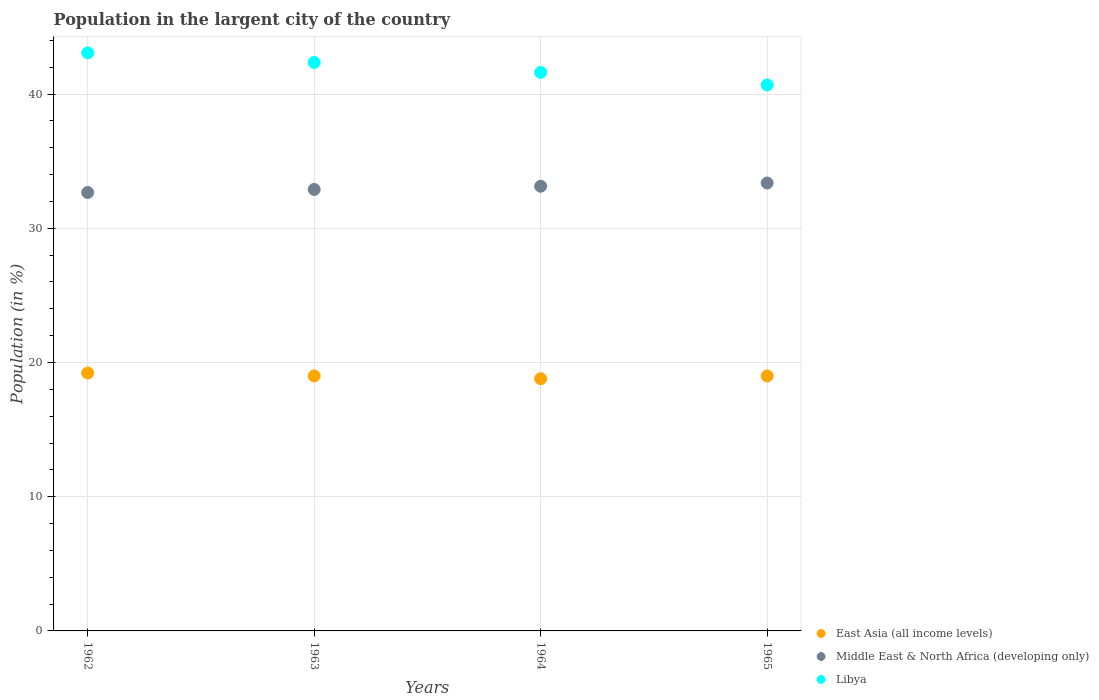How many different coloured dotlines are there?
Provide a short and direct response. 3. What is the percentage of population in the largent city in Libya in 1962?
Your answer should be compact. 43.07. Across all years, what is the maximum percentage of population in the largent city in Middle East & North Africa (developing only)?
Offer a terse response. 33.37. Across all years, what is the minimum percentage of population in the largent city in Middle East & North Africa (developing only)?
Offer a very short reply. 32.67. In which year was the percentage of population in the largent city in Libya maximum?
Offer a terse response. 1962. What is the total percentage of population in the largent city in East Asia (all income levels) in the graph?
Provide a short and direct response. 76.01. What is the difference between the percentage of population in the largent city in East Asia (all income levels) in 1962 and that in 1965?
Your answer should be very brief. 0.22. What is the difference between the percentage of population in the largent city in Libya in 1962 and the percentage of population in the largent city in Middle East & North Africa (developing only) in 1965?
Offer a terse response. 9.7. What is the average percentage of population in the largent city in East Asia (all income levels) per year?
Provide a short and direct response. 19. In the year 1965, what is the difference between the percentage of population in the largent city in Middle East & North Africa (developing only) and percentage of population in the largent city in East Asia (all income levels)?
Keep it short and to the point. 14.37. What is the ratio of the percentage of population in the largent city in Middle East & North Africa (developing only) in 1963 to that in 1964?
Offer a terse response. 0.99. Is the percentage of population in the largent city in Libya in 1962 less than that in 1965?
Offer a terse response. No. What is the difference between the highest and the second highest percentage of population in the largent city in Libya?
Provide a succinct answer. 0.71. What is the difference between the highest and the lowest percentage of population in the largent city in East Asia (all income levels)?
Make the answer very short. 0.42. Is it the case that in every year, the sum of the percentage of population in the largent city in Libya and percentage of population in the largent city in East Asia (all income levels)  is greater than the percentage of population in the largent city in Middle East & North Africa (developing only)?
Provide a short and direct response. Yes. Does the percentage of population in the largent city in East Asia (all income levels) monotonically increase over the years?
Keep it short and to the point. No. How many dotlines are there?
Make the answer very short. 3. How many years are there in the graph?
Give a very brief answer. 4. Are the values on the major ticks of Y-axis written in scientific E-notation?
Provide a short and direct response. No. Does the graph contain any zero values?
Keep it short and to the point. No. Does the graph contain grids?
Give a very brief answer. Yes. Where does the legend appear in the graph?
Provide a succinct answer. Bottom right. How are the legend labels stacked?
Your answer should be very brief. Vertical. What is the title of the graph?
Make the answer very short. Population in the largent city of the country. What is the label or title of the X-axis?
Give a very brief answer. Years. What is the label or title of the Y-axis?
Your answer should be compact. Population (in %). What is the Population (in %) of East Asia (all income levels) in 1962?
Offer a terse response. 19.22. What is the Population (in %) in Middle East & North Africa (developing only) in 1962?
Offer a very short reply. 32.67. What is the Population (in %) in Libya in 1962?
Give a very brief answer. 43.07. What is the Population (in %) in East Asia (all income levels) in 1963?
Ensure brevity in your answer.  19. What is the Population (in %) of Middle East & North Africa (developing only) in 1963?
Offer a very short reply. 32.89. What is the Population (in %) in Libya in 1963?
Provide a short and direct response. 42.36. What is the Population (in %) in East Asia (all income levels) in 1964?
Keep it short and to the point. 18.79. What is the Population (in %) of Middle East & North Africa (developing only) in 1964?
Provide a succinct answer. 33.13. What is the Population (in %) of Libya in 1964?
Your answer should be very brief. 41.62. What is the Population (in %) in East Asia (all income levels) in 1965?
Offer a very short reply. 19. What is the Population (in %) of Middle East & North Africa (developing only) in 1965?
Give a very brief answer. 33.37. What is the Population (in %) in Libya in 1965?
Offer a terse response. 40.68. Across all years, what is the maximum Population (in %) of East Asia (all income levels)?
Your answer should be very brief. 19.22. Across all years, what is the maximum Population (in %) of Middle East & North Africa (developing only)?
Provide a succinct answer. 33.37. Across all years, what is the maximum Population (in %) in Libya?
Make the answer very short. 43.07. Across all years, what is the minimum Population (in %) of East Asia (all income levels)?
Keep it short and to the point. 18.79. Across all years, what is the minimum Population (in %) of Middle East & North Africa (developing only)?
Make the answer very short. 32.67. Across all years, what is the minimum Population (in %) of Libya?
Give a very brief answer. 40.68. What is the total Population (in %) of East Asia (all income levels) in the graph?
Offer a very short reply. 76.01. What is the total Population (in %) of Middle East & North Africa (developing only) in the graph?
Keep it short and to the point. 132.07. What is the total Population (in %) in Libya in the graph?
Ensure brevity in your answer.  167.72. What is the difference between the Population (in %) of East Asia (all income levels) in 1962 and that in 1963?
Provide a succinct answer. 0.22. What is the difference between the Population (in %) in Middle East & North Africa (developing only) in 1962 and that in 1963?
Offer a terse response. -0.23. What is the difference between the Population (in %) of Libya in 1962 and that in 1963?
Give a very brief answer. 0.71. What is the difference between the Population (in %) in East Asia (all income levels) in 1962 and that in 1964?
Ensure brevity in your answer.  0.42. What is the difference between the Population (in %) of Middle East & North Africa (developing only) in 1962 and that in 1964?
Offer a very short reply. -0.46. What is the difference between the Population (in %) of Libya in 1962 and that in 1964?
Keep it short and to the point. 1.45. What is the difference between the Population (in %) of East Asia (all income levels) in 1962 and that in 1965?
Make the answer very short. 0.22. What is the difference between the Population (in %) of Middle East & North Africa (developing only) in 1962 and that in 1965?
Your answer should be very brief. -0.7. What is the difference between the Population (in %) of Libya in 1962 and that in 1965?
Keep it short and to the point. 2.39. What is the difference between the Population (in %) in East Asia (all income levels) in 1963 and that in 1964?
Make the answer very short. 0.21. What is the difference between the Population (in %) in Middle East & North Africa (developing only) in 1963 and that in 1964?
Keep it short and to the point. -0.24. What is the difference between the Population (in %) of Libya in 1963 and that in 1964?
Your answer should be very brief. 0.74. What is the difference between the Population (in %) in East Asia (all income levels) in 1963 and that in 1965?
Ensure brevity in your answer.  0. What is the difference between the Population (in %) in Middle East & North Africa (developing only) in 1963 and that in 1965?
Your answer should be compact. -0.48. What is the difference between the Population (in %) of Libya in 1963 and that in 1965?
Offer a terse response. 1.68. What is the difference between the Population (in %) of East Asia (all income levels) in 1964 and that in 1965?
Give a very brief answer. -0.2. What is the difference between the Population (in %) in Middle East & North Africa (developing only) in 1964 and that in 1965?
Ensure brevity in your answer.  -0.24. What is the difference between the Population (in %) of Libya in 1964 and that in 1965?
Provide a succinct answer. 0.94. What is the difference between the Population (in %) of East Asia (all income levels) in 1962 and the Population (in %) of Middle East & North Africa (developing only) in 1963?
Offer a very short reply. -13.68. What is the difference between the Population (in %) of East Asia (all income levels) in 1962 and the Population (in %) of Libya in 1963?
Give a very brief answer. -23.14. What is the difference between the Population (in %) of Middle East & North Africa (developing only) in 1962 and the Population (in %) of Libya in 1963?
Your response must be concise. -9.69. What is the difference between the Population (in %) of East Asia (all income levels) in 1962 and the Population (in %) of Middle East & North Africa (developing only) in 1964?
Your answer should be very brief. -13.92. What is the difference between the Population (in %) of East Asia (all income levels) in 1962 and the Population (in %) of Libya in 1964?
Give a very brief answer. -22.4. What is the difference between the Population (in %) in Middle East & North Africa (developing only) in 1962 and the Population (in %) in Libya in 1964?
Offer a very short reply. -8.95. What is the difference between the Population (in %) in East Asia (all income levels) in 1962 and the Population (in %) in Middle East & North Africa (developing only) in 1965?
Provide a succinct answer. -14.15. What is the difference between the Population (in %) in East Asia (all income levels) in 1962 and the Population (in %) in Libya in 1965?
Offer a very short reply. -21.46. What is the difference between the Population (in %) in Middle East & North Africa (developing only) in 1962 and the Population (in %) in Libya in 1965?
Your answer should be compact. -8.01. What is the difference between the Population (in %) of East Asia (all income levels) in 1963 and the Population (in %) of Middle East & North Africa (developing only) in 1964?
Offer a very short reply. -14.13. What is the difference between the Population (in %) of East Asia (all income levels) in 1963 and the Population (in %) of Libya in 1964?
Make the answer very short. -22.62. What is the difference between the Population (in %) of Middle East & North Africa (developing only) in 1963 and the Population (in %) of Libya in 1964?
Make the answer very short. -8.72. What is the difference between the Population (in %) in East Asia (all income levels) in 1963 and the Population (in %) in Middle East & North Africa (developing only) in 1965?
Offer a terse response. -14.37. What is the difference between the Population (in %) in East Asia (all income levels) in 1963 and the Population (in %) in Libya in 1965?
Make the answer very short. -21.68. What is the difference between the Population (in %) in Middle East & North Africa (developing only) in 1963 and the Population (in %) in Libya in 1965?
Ensure brevity in your answer.  -7.79. What is the difference between the Population (in %) of East Asia (all income levels) in 1964 and the Population (in %) of Middle East & North Africa (developing only) in 1965?
Ensure brevity in your answer.  -14.58. What is the difference between the Population (in %) of East Asia (all income levels) in 1964 and the Population (in %) of Libya in 1965?
Your response must be concise. -21.89. What is the difference between the Population (in %) of Middle East & North Africa (developing only) in 1964 and the Population (in %) of Libya in 1965?
Your answer should be very brief. -7.55. What is the average Population (in %) of East Asia (all income levels) per year?
Keep it short and to the point. 19. What is the average Population (in %) in Middle East & North Africa (developing only) per year?
Your answer should be compact. 33.02. What is the average Population (in %) of Libya per year?
Provide a short and direct response. 41.93. In the year 1962, what is the difference between the Population (in %) of East Asia (all income levels) and Population (in %) of Middle East & North Africa (developing only)?
Offer a terse response. -13.45. In the year 1962, what is the difference between the Population (in %) of East Asia (all income levels) and Population (in %) of Libya?
Your response must be concise. -23.85. In the year 1962, what is the difference between the Population (in %) in Middle East & North Africa (developing only) and Population (in %) in Libya?
Provide a succinct answer. -10.4. In the year 1963, what is the difference between the Population (in %) in East Asia (all income levels) and Population (in %) in Middle East & North Africa (developing only)?
Offer a very short reply. -13.89. In the year 1963, what is the difference between the Population (in %) of East Asia (all income levels) and Population (in %) of Libya?
Provide a short and direct response. -23.36. In the year 1963, what is the difference between the Population (in %) in Middle East & North Africa (developing only) and Population (in %) in Libya?
Make the answer very short. -9.46. In the year 1964, what is the difference between the Population (in %) in East Asia (all income levels) and Population (in %) in Middle East & North Africa (developing only)?
Ensure brevity in your answer.  -14.34. In the year 1964, what is the difference between the Population (in %) of East Asia (all income levels) and Population (in %) of Libya?
Your response must be concise. -22.82. In the year 1964, what is the difference between the Population (in %) of Middle East & North Africa (developing only) and Population (in %) of Libya?
Provide a succinct answer. -8.48. In the year 1965, what is the difference between the Population (in %) in East Asia (all income levels) and Population (in %) in Middle East & North Africa (developing only)?
Make the answer very short. -14.37. In the year 1965, what is the difference between the Population (in %) in East Asia (all income levels) and Population (in %) in Libya?
Provide a short and direct response. -21.68. In the year 1965, what is the difference between the Population (in %) of Middle East & North Africa (developing only) and Population (in %) of Libya?
Keep it short and to the point. -7.31. What is the ratio of the Population (in %) of East Asia (all income levels) in 1962 to that in 1963?
Keep it short and to the point. 1.01. What is the ratio of the Population (in %) in Middle East & North Africa (developing only) in 1962 to that in 1963?
Offer a very short reply. 0.99. What is the ratio of the Population (in %) of Libya in 1962 to that in 1963?
Ensure brevity in your answer.  1.02. What is the ratio of the Population (in %) of East Asia (all income levels) in 1962 to that in 1964?
Offer a very short reply. 1.02. What is the ratio of the Population (in %) in Libya in 1962 to that in 1964?
Make the answer very short. 1.03. What is the ratio of the Population (in %) in East Asia (all income levels) in 1962 to that in 1965?
Offer a terse response. 1.01. What is the ratio of the Population (in %) of Middle East & North Africa (developing only) in 1962 to that in 1965?
Give a very brief answer. 0.98. What is the ratio of the Population (in %) in Libya in 1962 to that in 1965?
Your answer should be compact. 1.06. What is the ratio of the Population (in %) of East Asia (all income levels) in 1963 to that in 1964?
Ensure brevity in your answer.  1.01. What is the ratio of the Population (in %) of Middle East & North Africa (developing only) in 1963 to that in 1964?
Give a very brief answer. 0.99. What is the ratio of the Population (in %) of Libya in 1963 to that in 1964?
Provide a succinct answer. 1.02. What is the ratio of the Population (in %) of Middle East & North Africa (developing only) in 1963 to that in 1965?
Offer a very short reply. 0.99. What is the ratio of the Population (in %) in Libya in 1963 to that in 1965?
Make the answer very short. 1.04. What is the ratio of the Population (in %) of East Asia (all income levels) in 1964 to that in 1965?
Provide a short and direct response. 0.99. What is the difference between the highest and the second highest Population (in %) of East Asia (all income levels)?
Offer a terse response. 0.22. What is the difference between the highest and the second highest Population (in %) of Middle East & North Africa (developing only)?
Give a very brief answer. 0.24. What is the difference between the highest and the second highest Population (in %) in Libya?
Make the answer very short. 0.71. What is the difference between the highest and the lowest Population (in %) of East Asia (all income levels)?
Offer a very short reply. 0.42. What is the difference between the highest and the lowest Population (in %) of Middle East & North Africa (developing only)?
Ensure brevity in your answer.  0.7. What is the difference between the highest and the lowest Population (in %) of Libya?
Offer a very short reply. 2.39. 